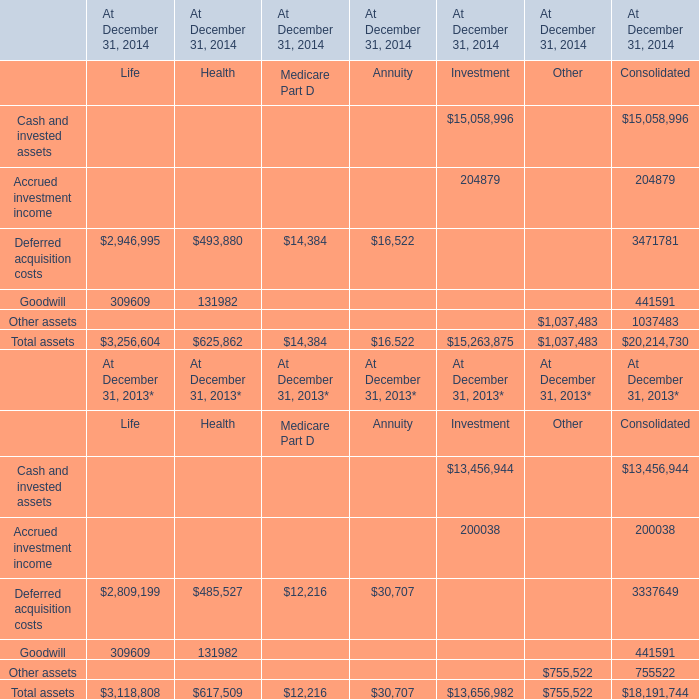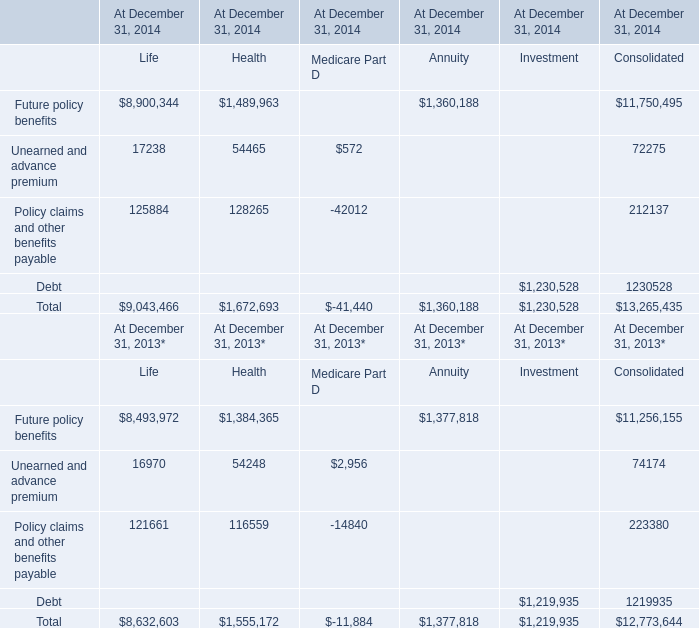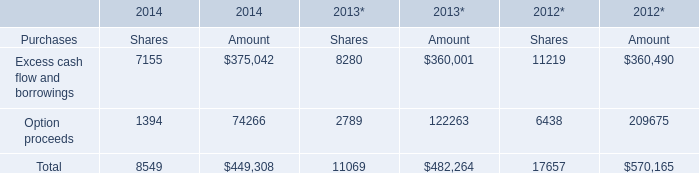What's the sum of Future policy benefits of At December 31, 2014 Life, and Other assets of At December 31, 2014 Other ? 
Computations: (8900344.0 + 755522.0)
Answer: 9655866.0. 